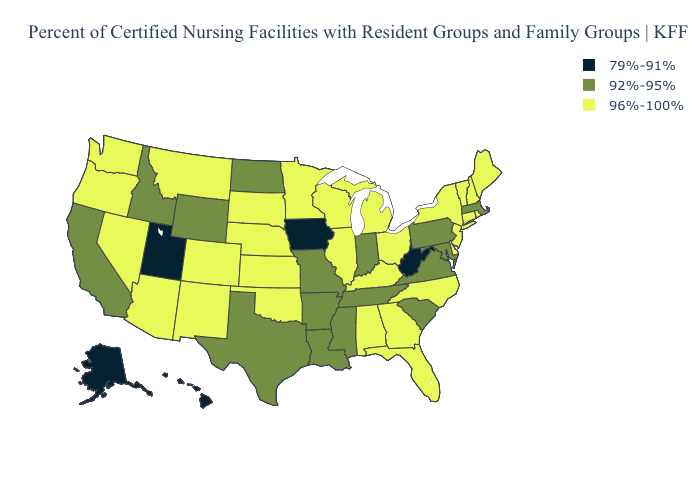What is the highest value in states that border West Virginia?
Be succinct. 96%-100%. What is the lowest value in the West?
Keep it brief. 79%-91%. Does Pennsylvania have the same value as Maine?
Write a very short answer. No. What is the value of New Mexico?
Short answer required. 96%-100%. Does Pennsylvania have the highest value in the Northeast?
Give a very brief answer. No. What is the value of Colorado?
Answer briefly. 96%-100%. Name the states that have a value in the range 79%-91%?
Keep it brief. Alaska, Hawaii, Iowa, Utah, West Virginia. Name the states that have a value in the range 96%-100%?
Write a very short answer. Alabama, Arizona, Colorado, Connecticut, Delaware, Florida, Georgia, Illinois, Kansas, Kentucky, Maine, Michigan, Minnesota, Montana, Nebraska, Nevada, New Hampshire, New Jersey, New Mexico, New York, North Carolina, Ohio, Oklahoma, Oregon, Rhode Island, South Dakota, Vermont, Washington, Wisconsin. Is the legend a continuous bar?
Quick response, please. No. Does Louisiana have a lower value than Arizona?
Short answer required. Yes. Name the states that have a value in the range 79%-91%?
Answer briefly. Alaska, Hawaii, Iowa, Utah, West Virginia. Name the states that have a value in the range 96%-100%?
Concise answer only. Alabama, Arizona, Colorado, Connecticut, Delaware, Florida, Georgia, Illinois, Kansas, Kentucky, Maine, Michigan, Minnesota, Montana, Nebraska, Nevada, New Hampshire, New Jersey, New Mexico, New York, North Carolina, Ohio, Oklahoma, Oregon, Rhode Island, South Dakota, Vermont, Washington, Wisconsin. What is the value of Utah?
Answer briefly. 79%-91%. Does the map have missing data?
Concise answer only. No. 